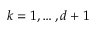Convert formula to latex. <formula><loc_0><loc_0><loc_500><loc_500>k = 1 , \dots , d + 1</formula> 